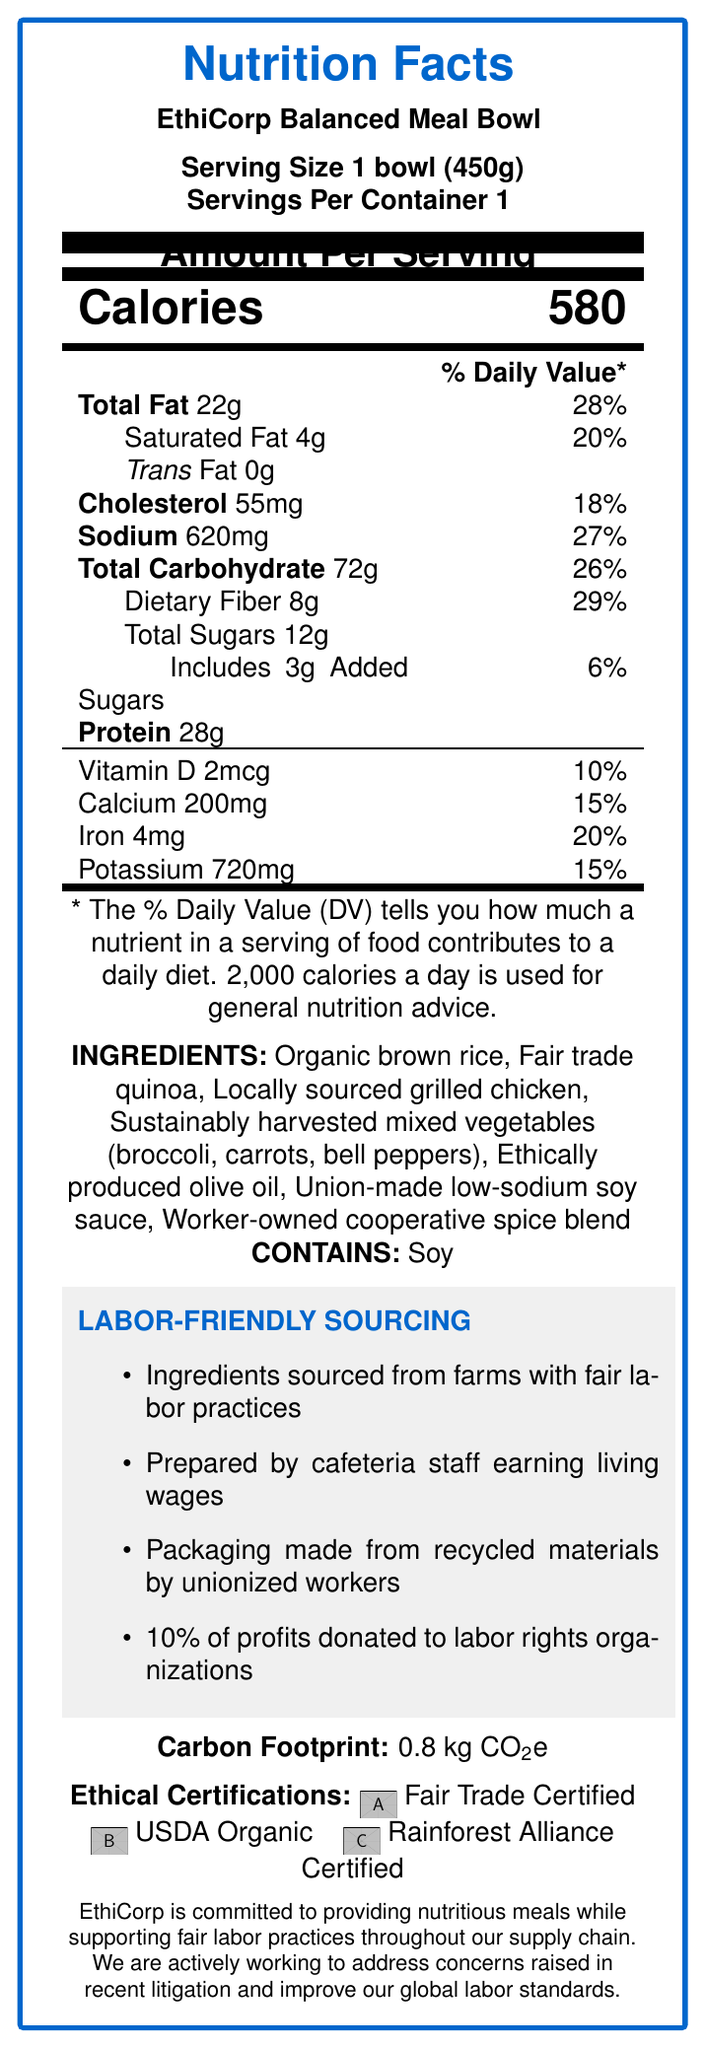what is the serving size of the EthiCorp Balanced Meal Bowl? The serving size is stated at the beginning of the document, specifying "Serving Size 1 bowl (450g)".
Answer: 1 bowl (450g) how many calories are in one serving? The document explicitly lists the amount of calories per serving as "580" right below the serving information.
Answer: 580 name three ingredients in the EthiCorp Balanced Meal Bowl. The ingredients are listed in the section labeled "INGREDIENTS".
Answer: Organic brown rice, Fair trade quinoa, Locally sourced grilled chicken what is the percentage daily value of sodium? The percentage daily value of sodium is stated as "27%" in the nutrition facts section.
Answer: 27% what allergens are present in the EthiCorp Balanced Meal Bowl? The allergens are listed right after the ingredients under the heading "CONTAINS".
Answer: Soy What is the percentage of profits donated to labor rights organizations? The document mentions "10% of profits donated to labor rights organizations" in the labor-friendly sourcing section.
Answer: 10% Where is the packaging for the EthiCorp Balanced Meal Bowl made? The labor-friendly sourcing section states that the packaging is "made from recycled materials by unionized workers".
Answer: Recycled materials by unionized workers Which of the following certifications does the EthiCorp Balanced Meal Bowl have? A. Fair Trade Certified B. Non-GMO Project Verified C. USDA Organic The meal bowl has "Fair Trade Certified" and "USDA Organic" certifications, as stated in the ethical certifications section.
Answer: A. Fair Trade Certified and C. USDA Organic How many grams of protein does the EthiCorp Balanced Meal Bowl contain? A. 22g B. 28g C. 35g D. 40g The document states that the bowl contains "28g" of protein.
Answer: B Does the EthiCorp Balanced Meal Bowl contain trans fat? The document specifies that the trans fat content is "0g", indicating no trans fat.
Answer: No Summarize the main idea of the EthiCorp Balanced Meal Bowl's Nutrition Facts Label. The label includes key nutritional data (calories, fats, sodium, sugars, etc.), ingredients highlight ethical sourcing, labor-friendly practices such as fair wages, and certifications like Fair Trade and USDA Organic.
Answer: The EthiCorp Balanced Meal Bowl's Nutrition Facts Label provides detailed nutritional information, ingredient list, allergen information, and emphasizes labor-friendly sourcing and ethical certifications, supporting fair labor practices and sustainability. Is there enough information to determine the price of the EthiCorp Balanced Meal Bowl? The document does not provide any information about the price of the EthiCorp Balanced Meal Bowl.
Answer: No What is the document's purpose? The document serves to inform about the nutritional content of the meal and the company's efforts in ethical sourcing and labor practices, as highlighted in various sections including the company statement.
Answer: Nutritional information and labor-friendly sourcing details about the EthiCorp Balanced Meal Bowl 